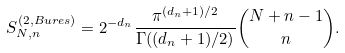<formula> <loc_0><loc_0><loc_500><loc_500>S ^ { ( 2 , B u r e s ) } _ { N , n } = 2 ^ { - d _ { n } } \frac { \pi ^ { ( d _ { n } + 1 ) / 2 } } { \Gamma ( ( d _ { n } + 1 ) / 2 ) } \binom { N + n - 1 } { n } .</formula> 